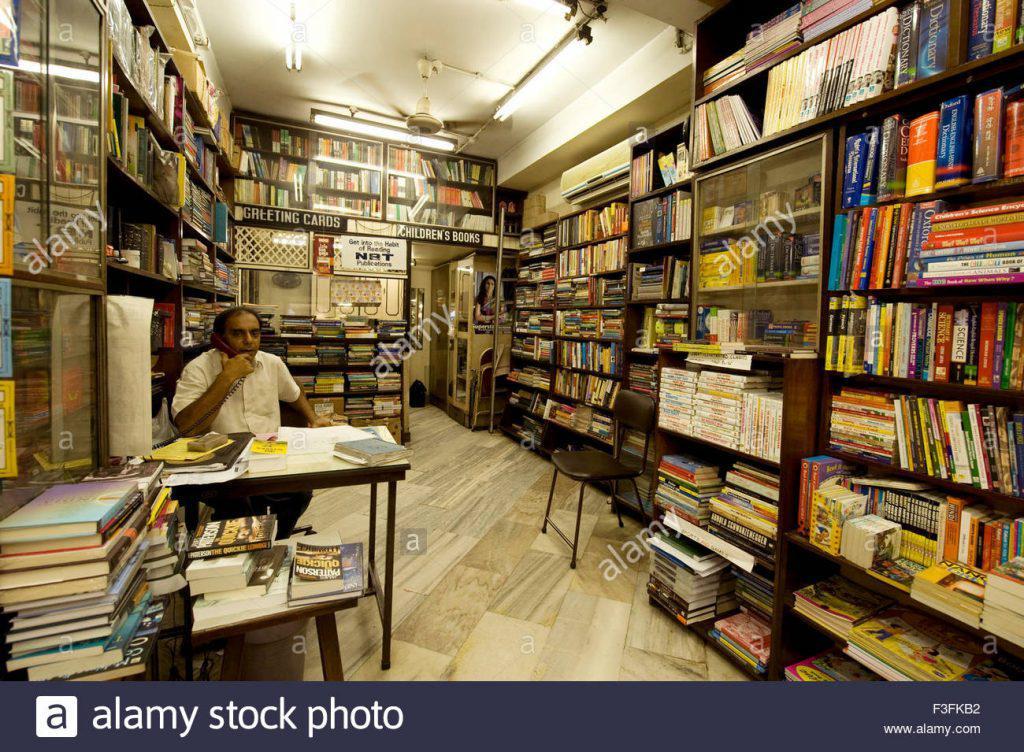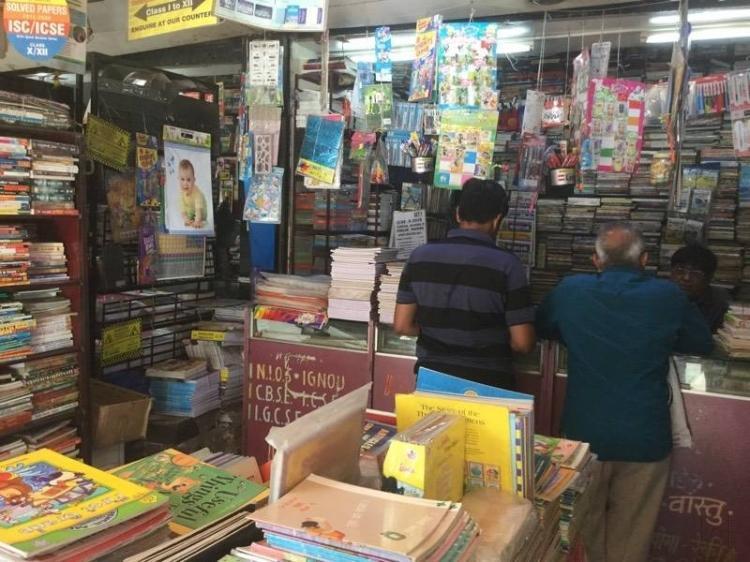The first image is the image on the left, the second image is the image on the right. Analyze the images presented: Is the assertion "One of the stores is Modern Book Shop." valid? Answer yes or no. No. The first image is the image on the left, the second image is the image on the right. Examine the images to the left and right. Is the description "there is an open door in one of the images" accurate? Answer yes or no. Yes. 